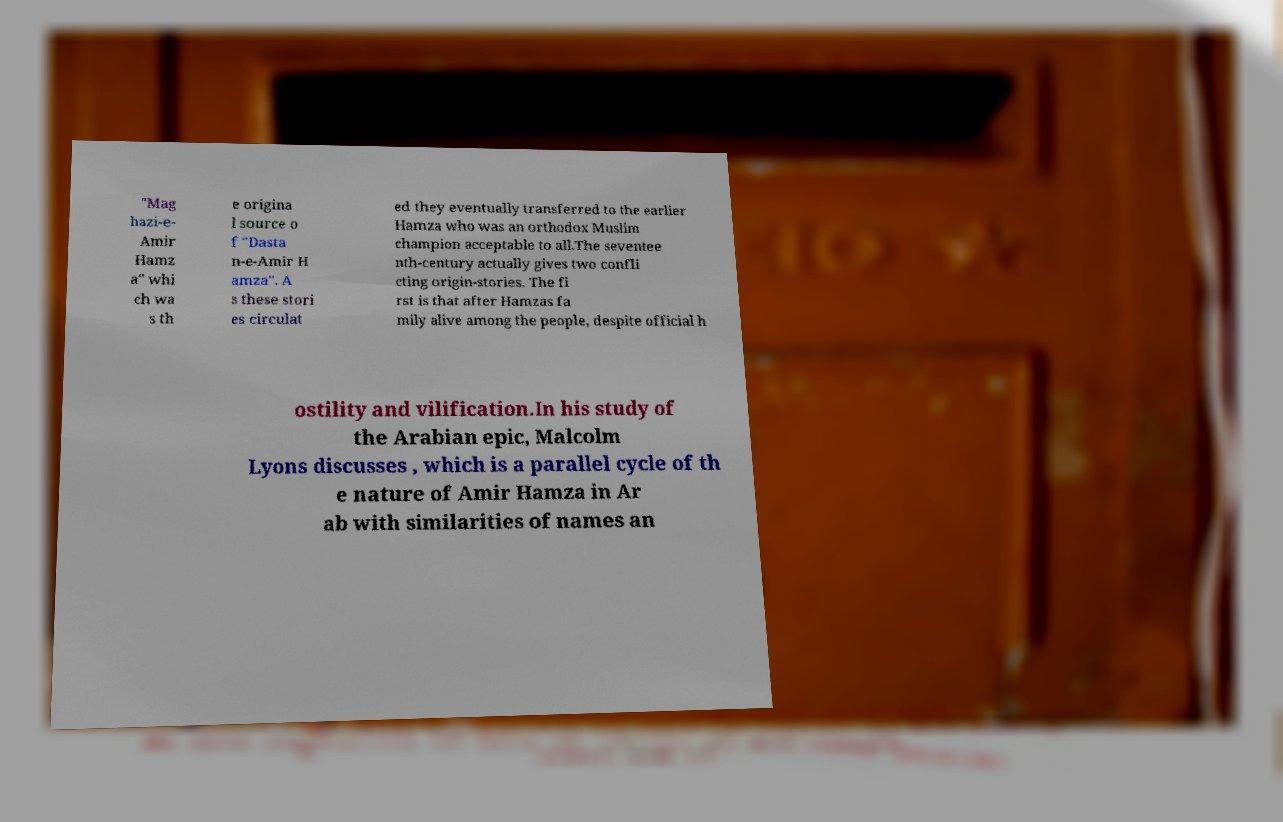Could you extract and type out the text from this image? "Mag hazi-e- Amir Hamz a" whi ch wa s th e origina l source o f "Dasta n-e-Amir H amza". A s these stori es circulat ed they eventually transferred to the earlier Hamza who was an orthodox Muslim champion acceptable to all.The seventee nth-century actually gives two confli cting origin-stories. The fi rst is that after Hamzas fa mily alive among the people, despite official h ostility and vilification.In his study of the Arabian epic, Malcolm Lyons discusses , which is a parallel cycle of th e nature of Amir Hamza in Ar ab with similarities of names an 